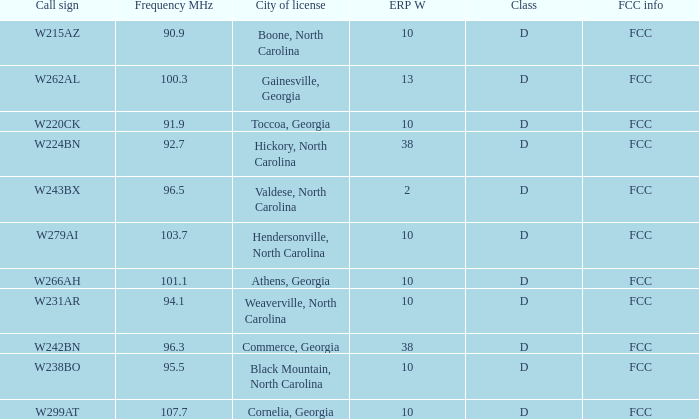What is the Frequency MHz for the station with a call sign of w224bn? 92.7. 